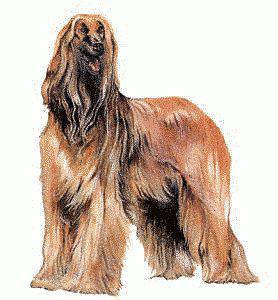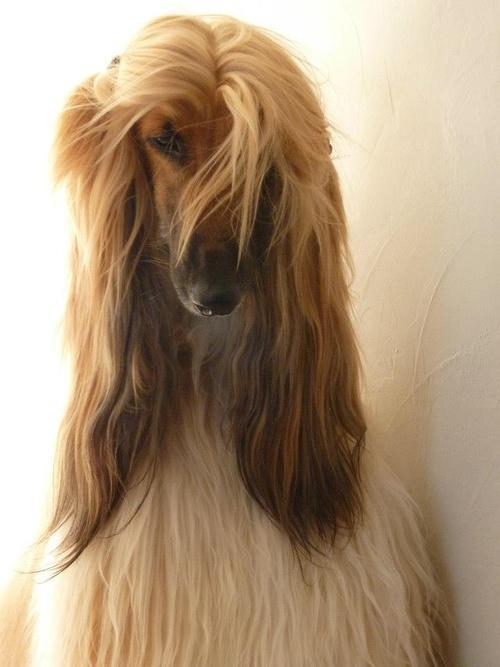The first image is the image on the left, the second image is the image on the right. Evaluate the accuracy of this statement regarding the images: "A leash extends diagonally from a top corner to one of the afghan hounds.". Is it true? Answer yes or no. No. 